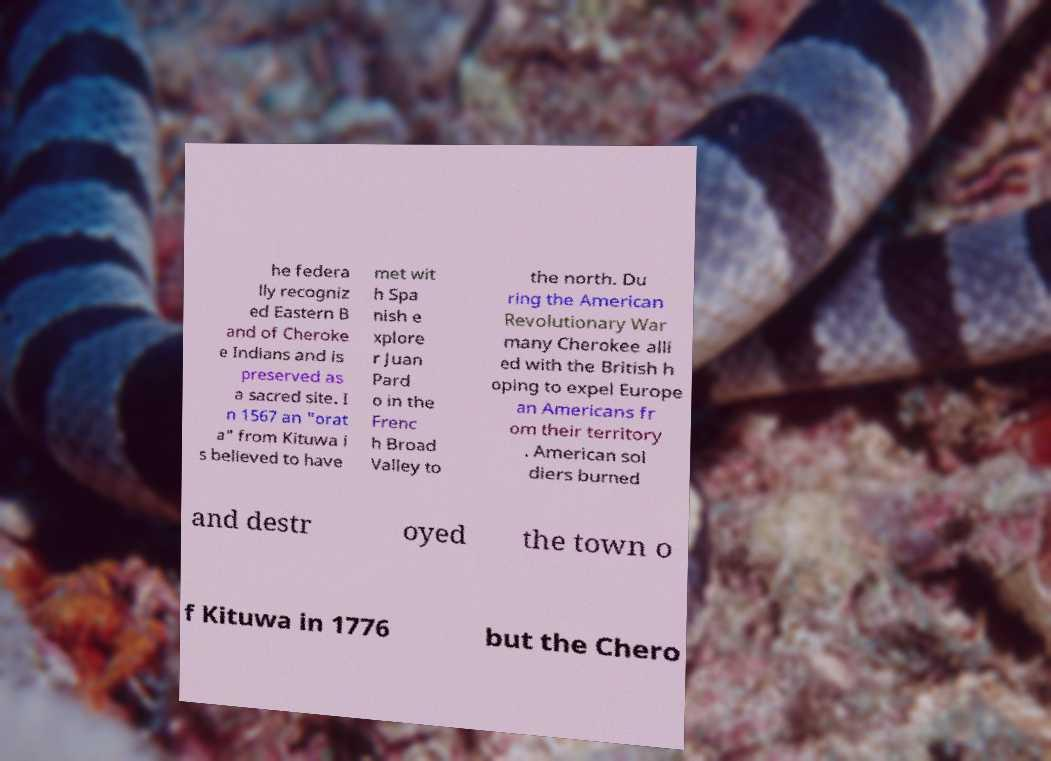Could you assist in decoding the text presented in this image and type it out clearly? he federa lly recogniz ed Eastern B and of Cheroke e Indians and is preserved as a sacred site. I n 1567 an "orat a" from Kituwa i s believed to have met wit h Spa nish e xplore r Juan Pard o in the Frenc h Broad Valley to the north. Du ring the American Revolutionary War many Cherokee alli ed with the British h oping to expel Europe an Americans fr om their territory . American sol diers burned and destr oyed the town o f Kituwa in 1776 but the Chero 